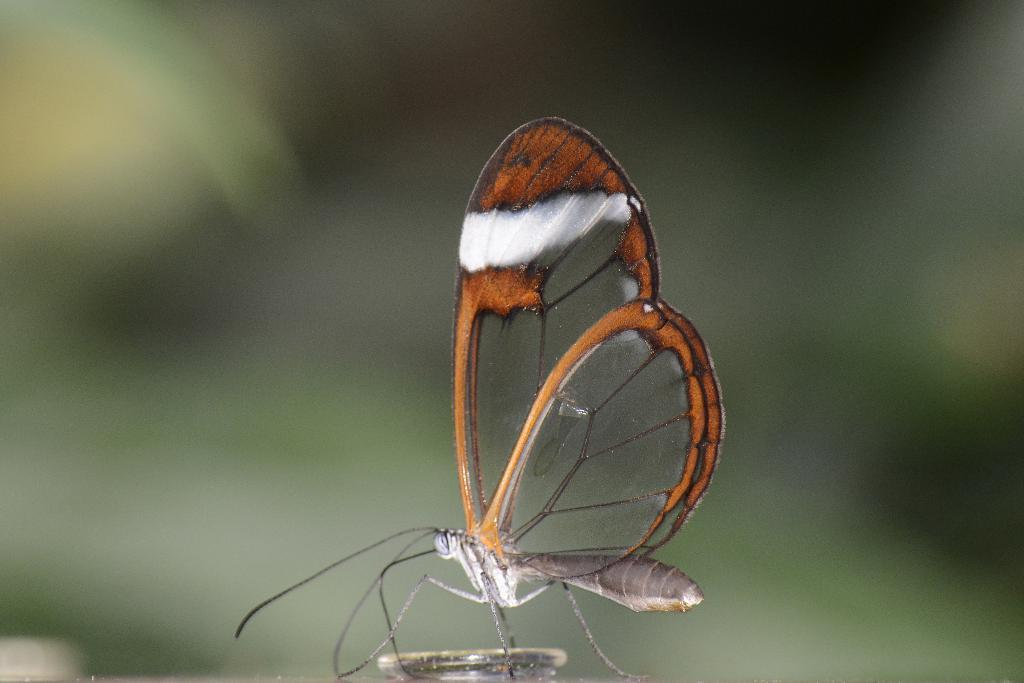What is the main subject of the image? There is a butterfly in the image. Can you describe the colors of the butterfly? The butterfly has black, orange, white, and ash colors. How would you describe the background of the image? The background of the image is blurry. What colors are present in the background? The background has green and black colors. What type of zebra can be seen in the image? There is no zebra present in the image; it features a butterfly with various colors. 